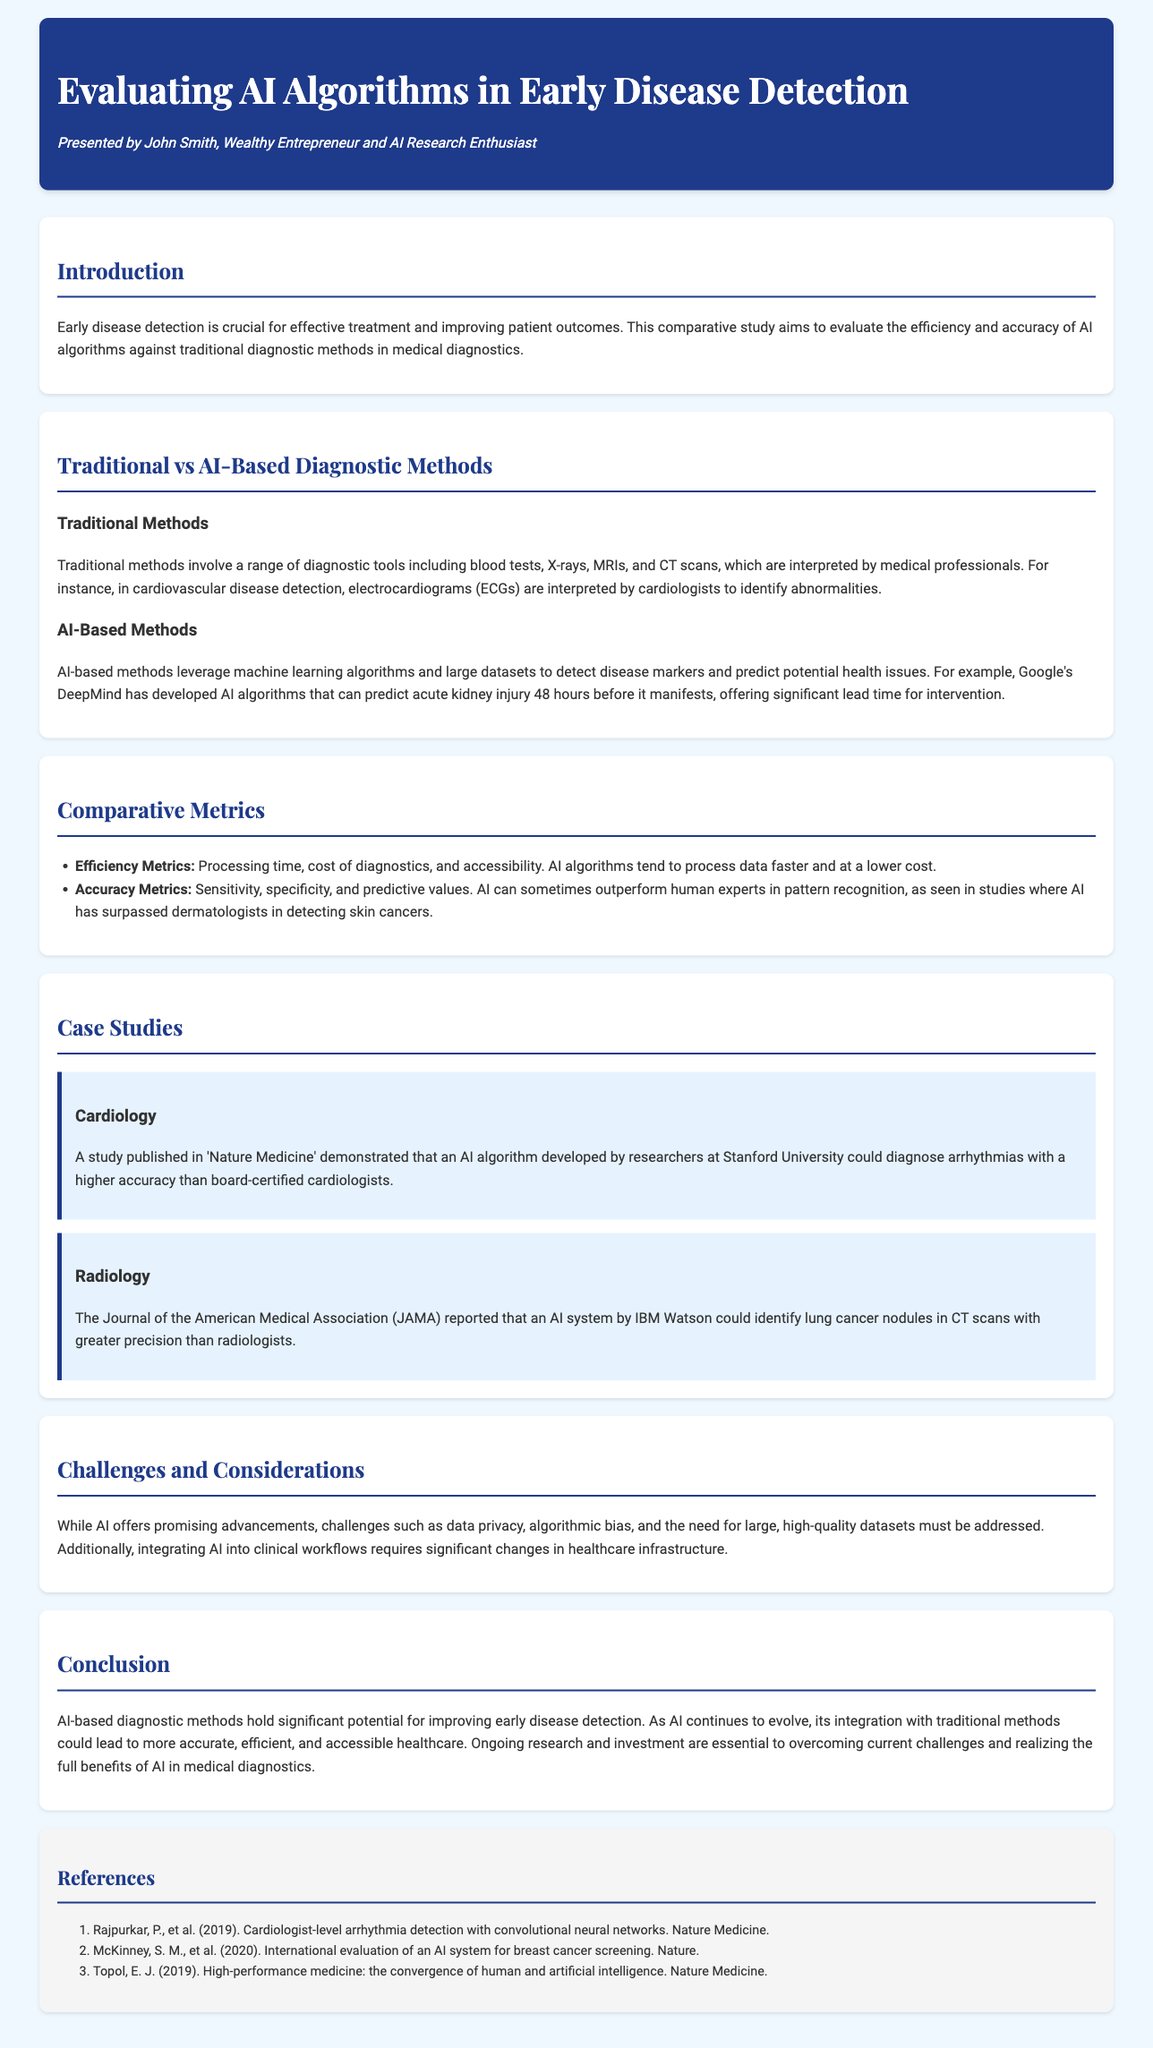What is the title of the study? The title of the study is provided in the header of the document.
Answer: Evaluating AI Algorithms in Early Disease Detection What is one traditional diagnostic method mentioned? The document lists various traditional methods under "Traditional Methods" section, one example can be directly cited.
Answer: ECGs What is a key advantage of AI-based methods according to the document? The document highlights certain advantages in the "AI-Based Methods" section, focusing on their predictive capabilities.
Answer: Lead time for intervention Which journal published the study regarding AI in cardiology? The document specifies the publication in which the cardiology case study appeared.
Answer: Nature Medicine What are the three accuracy metrics mentioned? The document outlines accuracy metrics in the "Comparative Metrics" section, indicating the specific types.
Answer: Sensitivity, specificity, predictive values What challenge does AI face in healthcare integration? The document mentions a specific challenge related to integrating AI into healthcare systems.
Answer: Infrastructure changes How is the AI algorithm by IBM Watson described in the document? The document includes descriptions of specific features of the AI algorithm in the context of radiology.
Answer: Greater precision Which case study highlights AI in lung cancer detection? The document provides a specific example of an AI application in lung cancer detection.
Answer: IBM Watson 